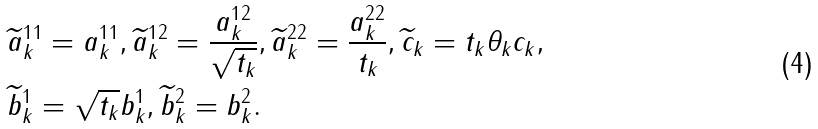<formula> <loc_0><loc_0><loc_500><loc_500>& \widetilde { a } _ { k } ^ { 1 1 } = a ^ { 1 1 } _ { k } , \widetilde { a } _ { k } ^ { 1 2 } = \frac { a _ { k } ^ { 1 2 } } { \sqrt { t _ { k } } } , \widetilde { a } ^ { 2 2 } _ { k } = \frac { a _ { k } ^ { 2 2 } } { t _ { k } } , \widetilde { c } _ { k } = t _ { k } \theta _ { k } c _ { k } , \\ & \widetilde { b } ^ { 1 } _ { k } = \sqrt { t _ { k } } b ^ { 1 } _ { k } , \widetilde { b } ^ { 2 } _ { k } = b ^ { 2 } _ { k } .</formula> 